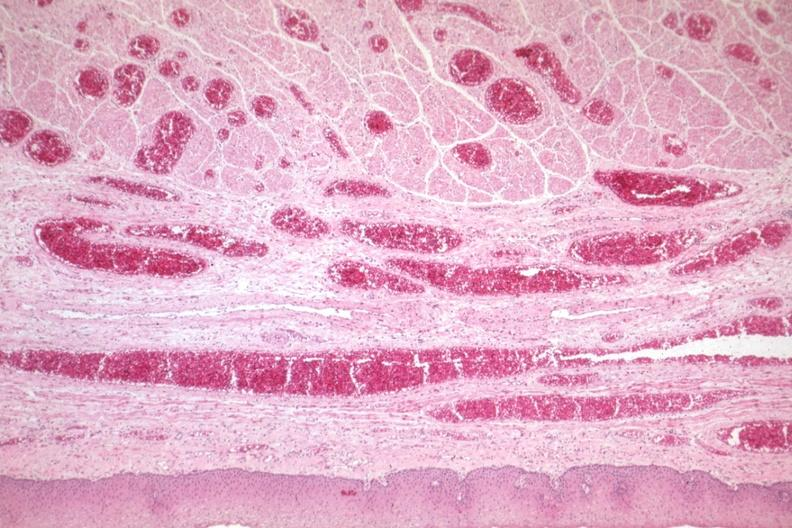what is good example of veins filled?
Answer the question using a single word or phrase. With blood 